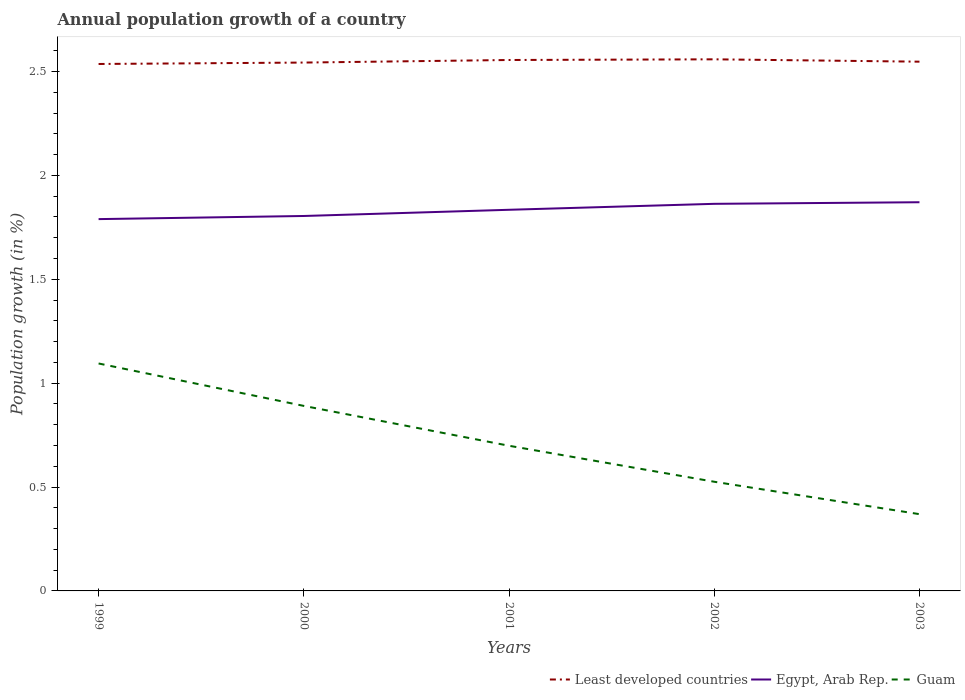How many different coloured lines are there?
Give a very brief answer. 3. Does the line corresponding to Egypt, Arab Rep. intersect with the line corresponding to Least developed countries?
Give a very brief answer. No. Across all years, what is the maximum annual population growth in Least developed countries?
Offer a very short reply. 2.54. What is the total annual population growth in Least developed countries in the graph?
Your answer should be very brief. -0.02. What is the difference between the highest and the second highest annual population growth in Egypt, Arab Rep.?
Your response must be concise. 0.08. What is the difference between the highest and the lowest annual population growth in Least developed countries?
Make the answer very short. 2. Is the annual population growth in Least developed countries strictly greater than the annual population growth in Egypt, Arab Rep. over the years?
Ensure brevity in your answer.  No. How many lines are there?
Keep it short and to the point. 3. What is the difference between two consecutive major ticks on the Y-axis?
Ensure brevity in your answer.  0.5. Are the values on the major ticks of Y-axis written in scientific E-notation?
Offer a very short reply. No. Does the graph contain any zero values?
Your answer should be compact. No. How many legend labels are there?
Your response must be concise. 3. How are the legend labels stacked?
Give a very brief answer. Horizontal. What is the title of the graph?
Your response must be concise. Annual population growth of a country. Does "St. Vincent and the Grenadines" appear as one of the legend labels in the graph?
Your answer should be very brief. No. What is the label or title of the X-axis?
Offer a very short reply. Years. What is the label or title of the Y-axis?
Your answer should be compact. Population growth (in %). What is the Population growth (in %) in Least developed countries in 1999?
Your answer should be very brief. 2.54. What is the Population growth (in %) in Egypt, Arab Rep. in 1999?
Offer a very short reply. 1.79. What is the Population growth (in %) of Guam in 1999?
Your answer should be compact. 1.09. What is the Population growth (in %) in Least developed countries in 2000?
Provide a short and direct response. 2.54. What is the Population growth (in %) in Egypt, Arab Rep. in 2000?
Ensure brevity in your answer.  1.8. What is the Population growth (in %) of Guam in 2000?
Offer a very short reply. 0.89. What is the Population growth (in %) in Least developed countries in 2001?
Your response must be concise. 2.56. What is the Population growth (in %) in Egypt, Arab Rep. in 2001?
Your response must be concise. 1.83. What is the Population growth (in %) in Guam in 2001?
Ensure brevity in your answer.  0.7. What is the Population growth (in %) in Least developed countries in 2002?
Give a very brief answer. 2.56. What is the Population growth (in %) in Egypt, Arab Rep. in 2002?
Keep it short and to the point. 1.86. What is the Population growth (in %) of Guam in 2002?
Your answer should be very brief. 0.53. What is the Population growth (in %) in Least developed countries in 2003?
Keep it short and to the point. 2.55. What is the Population growth (in %) of Egypt, Arab Rep. in 2003?
Offer a very short reply. 1.87. What is the Population growth (in %) in Guam in 2003?
Your answer should be compact. 0.37. Across all years, what is the maximum Population growth (in %) of Least developed countries?
Provide a succinct answer. 2.56. Across all years, what is the maximum Population growth (in %) of Egypt, Arab Rep.?
Ensure brevity in your answer.  1.87. Across all years, what is the maximum Population growth (in %) of Guam?
Provide a succinct answer. 1.09. Across all years, what is the minimum Population growth (in %) in Least developed countries?
Make the answer very short. 2.54. Across all years, what is the minimum Population growth (in %) of Egypt, Arab Rep.?
Your answer should be compact. 1.79. Across all years, what is the minimum Population growth (in %) in Guam?
Provide a short and direct response. 0.37. What is the total Population growth (in %) of Least developed countries in the graph?
Provide a succinct answer. 12.74. What is the total Population growth (in %) in Egypt, Arab Rep. in the graph?
Your answer should be compact. 9.16. What is the total Population growth (in %) in Guam in the graph?
Your answer should be very brief. 3.58. What is the difference between the Population growth (in %) in Least developed countries in 1999 and that in 2000?
Provide a short and direct response. -0.01. What is the difference between the Population growth (in %) in Egypt, Arab Rep. in 1999 and that in 2000?
Keep it short and to the point. -0.02. What is the difference between the Population growth (in %) in Guam in 1999 and that in 2000?
Provide a succinct answer. 0.2. What is the difference between the Population growth (in %) of Least developed countries in 1999 and that in 2001?
Offer a terse response. -0.02. What is the difference between the Population growth (in %) of Egypt, Arab Rep. in 1999 and that in 2001?
Provide a short and direct response. -0.04. What is the difference between the Population growth (in %) in Guam in 1999 and that in 2001?
Offer a terse response. 0.4. What is the difference between the Population growth (in %) in Least developed countries in 1999 and that in 2002?
Keep it short and to the point. -0.02. What is the difference between the Population growth (in %) in Egypt, Arab Rep. in 1999 and that in 2002?
Ensure brevity in your answer.  -0.07. What is the difference between the Population growth (in %) in Guam in 1999 and that in 2002?
Make the answer very short. 0.57. What is the difference between the Population growth (in %) of Least developed countries in 1999 and that in 2003?
Make the answer very short. -0.01. What is the difference between the Population growth (in %) in Egypt, Arab Rep. in 1999 and that in 2003?
Provide a succinct answer. -0.08. What is the difference between the Population growth (in %) in Guam in 1999 and that in 2003?
Make the answer very short. 0.73. What is the difference between the Population growth (in %) of Least developed countries in 2000 and that in 2001?
Offer a very short reply. -0.01. What is the difference between the Population growth (in %) of Egypt, Arab Rep. in 2000 and that in 2001?
Give a very brief answer. -0.03. What is the difference between the Population growth (in %) of Guam in 2000 and that in 2001?
Provide a succinct answer. 0.19. What is the difference between the Population growth (in %) of Least developed countries in 2000 and that in 2002?
Provide a succinct answer. -0.02. What is the difference between the Population growth (in %) of Egypt, Arab Rep. in 2000 and that in 2002?
Offer a very short reply. -0.06. What is the difference between the Population growth (in %) of Guam in 2000 and that in 2002?
Give a very brief answer. 0.36. What is the difference between the Population growth (in %) in Least developed countries in 2000 and that in 2003?
Provide a succinct answer. -0. What is the difference between the Population growth (in %) in Egypt, Arab Rep. in 2000 and that in 2003?
Offer a very short reply. -0.07. What is the difference between the Population growth (in %) in Guam in 2000 and that in 2003?
Offer a terse response. 0.52. What is the difference between the Population growth (in %) in Least developed countries in 2001 and that in 2002?
Provide a succinct answer. -0. What is the difference between the Population growth (in %) in Egypt, Arab Rep. in 2001 and that in 2002?
Offer a very short reply. -0.03. What is the difference between the Population growth (in %) in Guam in 2001 and that in 2002?
Make the answer very short. 0.17. What is the difference between the Population growth (in %) of Least developed countries in 2001 and that in 2003?
Give a very brief answer. 0.01. What is the difference between the Population growth (in %) in Egypt, Arab Rep. in 2001 and that in 2003?
Your response must be concise. -0.04. What is the difference between the Population growth (in %) of Guam in 2001 and that in 2003?
Offer a terse response. 0.33. What is the difference between the Population growth (in %) in Least developed countries in 2002 and that in 2003?
Your answer should be compact. 0.01. What is the difference between the Population growth (in %) in Egypt, Arab Rep. in 2002 and that in 2003?
Give a very brief answer. -0.01. What is the difference between the Population growth (in %) of Guam in 2002 and that in 2003?
Offer a very short reply. 0.16. What is the difference between the Population growth (in %) of Least developed countries in 1999 and the Population growth (in %) of Egypt, Arab Rep. in 2000?
Your answer should be very brief. 0.73. What is the difference between the Population growth (in %) of Least developed countries in 1999 and the Population growth (in %) of Guam in 2000?
Ensure brevity in your answer.  1.65. What is the difference between the Population growth (in %) in Egypt, Arab Rep. in 1999 and the Population growth (in %) in Guam in 2000?
Provide a short and direct response. 0.9. What is the difference between the Population growth (in %) in Least developed countries in 1999 and the Population growth (in %) in Egypt, Arab Rep. in 2001?
Ensure brevity in your answer.  0.7. What is the difference between the Population growth (in %) in Least developed countries in 1999 and the Population growth (in %) in Guam in 2001?
Provide a succinct answer. 1.84. What is the difference between the Population growth (in %) in Egypt, Arab Rep. in 1999 and the Population growth (in %) in Guam in 2001?
Give a very brief answer. 1.09. What is the difference between the Population growth (in %) of Least developed countries in 1999 and the Population growth (in %) of Egypt, Arab Rep. in 2002?
Your answer should be compact. 0.67. What is the difference between the Population growth (in %) of Least developed countries in 1999 and the Population growth (in %) of Guam in 2002?
Give a very brief answer. 2.01. What is the difference between the Population growth (in %) in Egypt, Arab Rep. in 1999 and the Population growth (in %) in Guam in 2002?
Provide a short and direct response. 1.26. What is the difference between the Population growth (in %) in Least developed countries in 1999 and the Population growth (in %) in Egypt, Arab Rep. in 2003?
Offer a very short reply. 0.67. What is the difference between the Population growth (in %) of Least developed countries in 1999 and the Population growth (in %) of Guam in 2003?
Give a very brief answer. 2.17. What is the difference between the Population growth (in %) of Egypt, Arab Rep. in 1999 and the Population growth (in %) of Guam in 2003?
Provide a succinct answer. 1.42. What is the difference between the Population growth (in %) in Least developed countries in 2000 and the Population growth (in %) in Egypt, Arab Rep. in 2001?
Make the answer very short. 0.71. What is the difference between the Population growth (in %) in Least developed countries in 2000 and the Population growth (in %) in Guam in 2001?
Provide a succinct answer. 1.84. What is the difference between the Population growth (in %) in Egypt, Arab Rep. in 2000 and the Population growth (in %) in Guam in 2001?
Provide a succinct answer. 1.11. What is the difference between the Population growth (in %) of Least developed countries in 2000 and the Population growth (in %) of Egypt, Arab Rep. in 2002?
Provide a succinct answer. 0.68. What is the difference between the Population growth (in %) of Least developed countries in 2000 and the Population growth (in %) of Guam in 2002?
Your answer should be very brief. 2.02. What is the difference between the Population growth (in %) in Egypt, Arab Rep. in 2000 and the Population growth (in %) in Guam in 2002?
Keep it short and to the point. 1.28. What is the difference between the Population growth (in %) in Least developed countries in 2000 and the Population growth (in %) in Egypt, Arab Rep. in 2003?
Offer a terse response. 0.67. What is the difference between the Population growth (in %) in Least developed countries in 2000 and the Population growth (in %) in Guam in 2003?
Offer a very short reply. 2.17. What is the difference between the Population growth (in %) of Egypt, Arab Rep. in 2000 and the Population growth (in %) of Guam in 2003?
Offer a very short reply. 1.44. What is the difference between the Population growth (in %) of Least developed countries in 2001 and the Population growth (in %) of Egypt, Arab Rep. in 2002?
Offer a terse response. 0.69. What is the difference between the Population growth (in %) of Least developed countries in 2001 and the Population growth (in %) of Guam in 2002?
Offer a very short reply. 2.03. What is the difference between the Population growth (in %) in Egypt, Arab Rep. in 2001 and the Population growth (in %) in Guam in 2002?
Your response must be concise. 1.31. What is the difference between the Population growth (in %) in Least developed countries in 2001 and the Population growth (in %) in Egypt, Arab Rep. in 2003?
Your response must be concise. 0.68. What is the difference between the Population growth (in %) of Least developed countries in 2001 and the Population growth (in %) of Guam in 2003?
Make the answer very short. 2.19. What is the difference between the Population growth (in %) in Egypt, Arab Rep. in 2001 and the Population growth (in %) in Guam in 2003?
Offer a very short reply. 1.46. What is the difference between the Population growth (in %) of Least developed countries in 2002 and the Population growth (in %) of Egypt, Arab Rep. in 2003?
Make the answer very short. 0.69. What is the difference between the Population growth (in %) of Least developed countries in 2002 and the Population growth (in %) of Guam in 2003?
Keep it short and to the point. 2.19. What is the difference between the Population growth (in %) of Egypt, Arab Rep. in 2002 and the Population growth (in %) of Guam in 2003?
Provide a short and direct response. 1.49. What is the average Population growth (in %) of Least developed countries per year?
Offer a terse response. 2.55. What is the average Population growth (in %) in Egypt, Arab Rep. per year?
Your answer should be very brief. 1.83. What is the average Population growth (in %) of Guam per year?
Make the answer very short. 0.72. In the year 1999, what is the difference between the Population growth (in %) of Least developed countries and Population growth (in %) of Egypt, Arab Rep.?
Give a very brief answer. 0.75. In the year 1999, what is the difference between the Population growth (in %) of Least developed countries and Population growth (in %) of Guam?
Offer a very short reply. 1.44. In the year 1999, what is the difference between the Population growth (in %) of Egypt, Arab Rep. and Population growth (in %) of Guam?
Make the answer very short. 0.69. In the year 2000, what is the difference between the Population growth (in %) of Least developed countries and Population growth (in %) of Egypt, Arab Rep.?
Make the answer very short. 0.74. In the year 2000, what is the difference between the Population growth (in %) of Least developed countries and Population growth (in %) of Guam?
Make the answer very short. 1.65. In the year 2000, what is the difference between the Population growth (in %) in Egypt, Arab Rep. and Population growth (in %) in Guam?
Provide a succinct answer. 0.91. In the year 2001, what is the difference between the Population growth (in %) in Least developed countries and Population growth (in %) in Egypt, Arab Rep.?
Provide a succinct answer. 0.72. In the year 2001, what is the difference between the Population growth (in %) of Least developed countries and Population growth (in %) of Guam?
Keep it short and to the point. 1.86. In the year 2001, what is the difference between the Population growth (in %) of Egypt, Arab Rep. and Population growth (in %) of Guam?
Provide a succinct answer. 1.14. In the year 2002, what is the difference between the Population growth (in %) in Least developed countries and Population growth (in %) in Egypt, Arab Rep.?
Offer a terse response. 0.7. In the year 2002, what is the difference between the Population growth (in %) in Least developed countries and Population growth (in %) in Guam?
Keep it short and to the point. 2.03. In the year 2002, what is the difference between the Population growth (in %) in Egypt, Arab Rep. and Population growth (in %) in Guam?
Give a very brief answer. 1.34. In the year 2003, what is the difference between the Population growth (in %) in Least developed countries and Population growth (in %) in Egypt, Arab Rep.?
Provide a succinct answer. 0.68. In the year 2003, what is the difference between the Population growth (in %) of Least developed countries and Population growth (in %) of Guam?
Keep it short and to the point. 2.18. In the year 2003, what is the difference between the Population growth (in %) of Egypt, Arab Rep. and Population growth (in %) of Guam?
Offer a very short reply. 1.5. What is the ratio of the Population growth (in %) in Least developed countries in 1999 to that in 2000?
Your response must be concise. 1. What is the ratio of the Population growth (in %) of Egypt, Arab Rep. in 1999 to that in 2000?
Keep it short and to the point. 0.99. What is the ratio of the Population growth (in %) of Guam in 1999 to that in 2000?
Ensure brevity in your answer.  1.23. What is the ratio of the Population growth (in %) of Least developed countries in 1999 to that in 2001?
Offer a terse response. 0.99. What is the ratio of the Population growth (in %) of Egypt, Arab Rep. in 1999 to that in 2001?
Provide a short and direct response. 0.98. What is the ratio of the Population growth (in %) in Guam in 1999 to that in 2001?
Make the answer very short. 1.57. What is the ratio of the Population growth (in %) of Least developed countries in 1999 to that in 2002?
Your answer should be compact. 0.99. What is the ratio of the Population growth (in %) in Egypt, Arab Rep. in 1999 to that in 2002?
Offer a terse response. 0.96. What is the ratio of the Population growth (in %) in Guam in 1999 to that in 2002?
Offer a terse response. 2.08. What is the ratio of the Population growth (in %) in Least developed countries in 1999 to that in 2003?
Offer a terse response. 1. What is the ratio of the Population growth (in %) of Egypt, Arab Rep. in 1999 to that in 2003?
Your response must be concise. 0.96. What is the ratio of the Population growth (in %) in Guam in 1999 to that in 2003?
Keep it short and to the point. 2.96. What is the ratio of the Population growth (in %) of Least developed countries in 2000 to that in 2001?
Give a very brief answer. 1. What is the ratio of the Population growth (in %) in Egypt, Arab Rep. in 2000 to that in 2001?
Provide a succinct answer. 0.98. What is the ratio of the Population growth (in %) of Guam in 2000 to that in 2001?
Make the answer very short. 1.27. What is the ratio of the Population growth (in %) in Egypt, Arab Rep. in 2000 to that in 2002?
Make the answer very short. 0.97. What is the ratio of the Population growth (in %) of Guam in 2000 to that in 2002?
Your response must be concise. 1.69. What is the ratio of the Population growth (in %) in Egypt, Arab Rep. in 2000 to that in 2003?
Your response must be concise. 0.96. What is the ratio of the Population growth (in %) in Guam in 2000 to that in 2003?
Ensure brevity in your answer.  2.41. What is the ratio of the Population growth (in %) of Egypt, Arab Rep. in 2001 to that in 2002?
Make the answer very short. 0.98. What is the ratio of the Population growth (in %) in Guam in 2001 to that in 2002?
Give a very brief answer. 1.33. What is the ratio of the Population growth (in %) of Least developed countries in 2001 to that in 2003?
Provide a succinct answer. 1. What is the ratio of the Population growth (in %) in Egypt, Arab Rep. in 2001 to that in 2003?
Offer a terse response. 0.98. What is the ratio of the Population growth (in %) in Guam in 2001 to that in 2003?
Ensure brevity in your answer.  1.89. What is the ratio of the Population growth (in %) in Least developed countries in 2002 to that in 2003?
Offer a very short reply. 1. What is the ratio of the Population growth (in %) in Guam in 2002 to that in 2003?
Your response must be concise. 1.42. What is the difference between the highest and the second highest Population growth (in %) in Least developed countries?
Provide a short and direct response. 0. What is the difference between the highest and the second highest Population growth (in %) of Egypt, Arab Rep.?
Keep it short and to the point. 0.01. What is the difference between the highest and the second highest Population growth (in %) in Guam?
Provide a succinct answer. 0.2. What is the difference between the highest and the lowest Population growth (in %) in Least developed countries?
Provide a succinct answer. 0.02. What is the difference between the highest and the lowest Population growth (in %) in Egypt, Arab Rep.?
Provide a short and direct response. 0.08. What is the difference between the highest and the lowest Population growth (in %) of Guam?
Give a very brief answer. 0.73. 